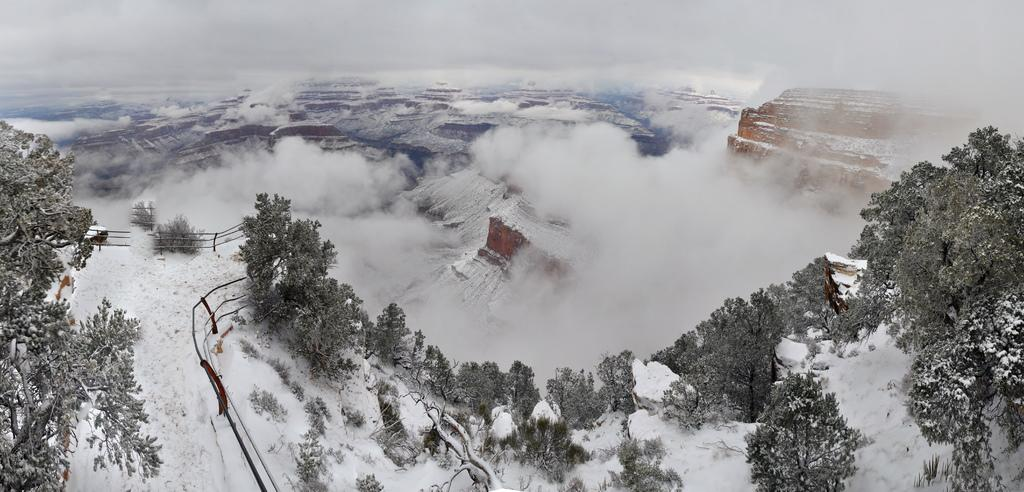What is the condition of the ground in the image? The ground is covered in snow. What can be seen in the front of the image? There are trees in the front of the image. What is visible in the background of the image? Snow and clouds are visible in the background. What feature is present on the left side of the image? There is railing on the left side of the image. How much money is being exchanged between the trees in the image? There is no exchange of money between the trees in the image, as trees are not capable of such transactions. 